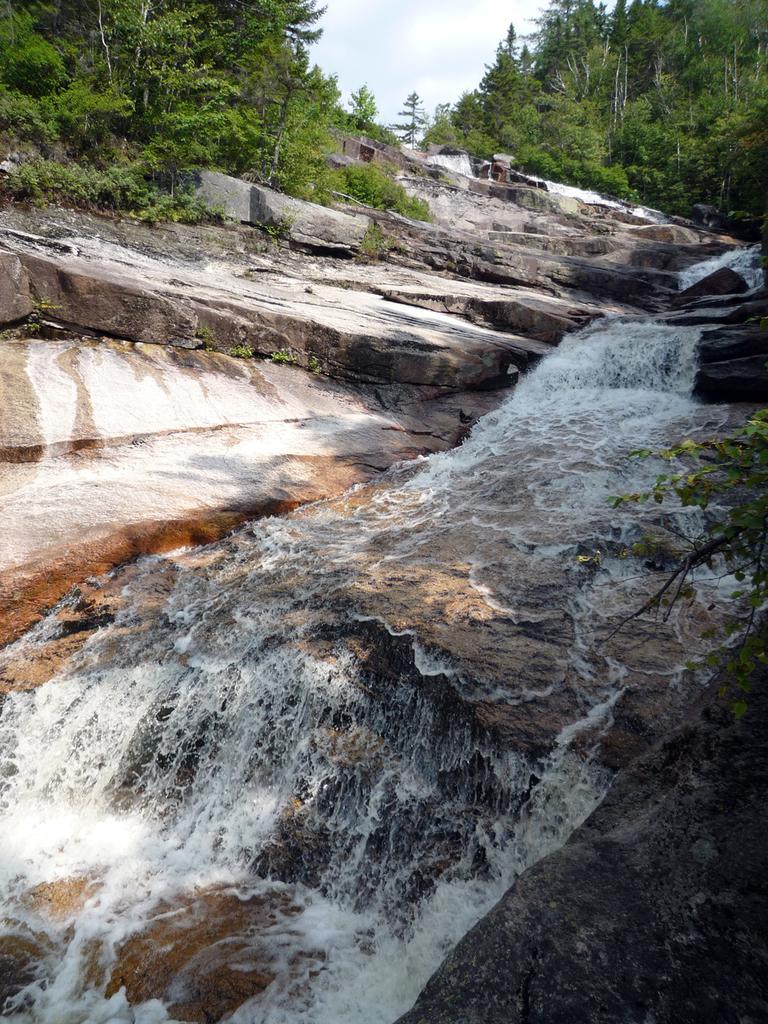What type of natural elements can be seen in the image? There are rocks, water, plants, and trees in the image. What part of the natural environment is visible in the image? The sky is visible in the image, along with clouds. Can you describe the water in the image? The water is present in the image, but its specific characteristics are not mentioned in the provided facts. How many clocks are hanging from the trees in the image? There are no clocks present in the image; it features natural elements such as rocks, water, plants, trees, sky, and clouds. 